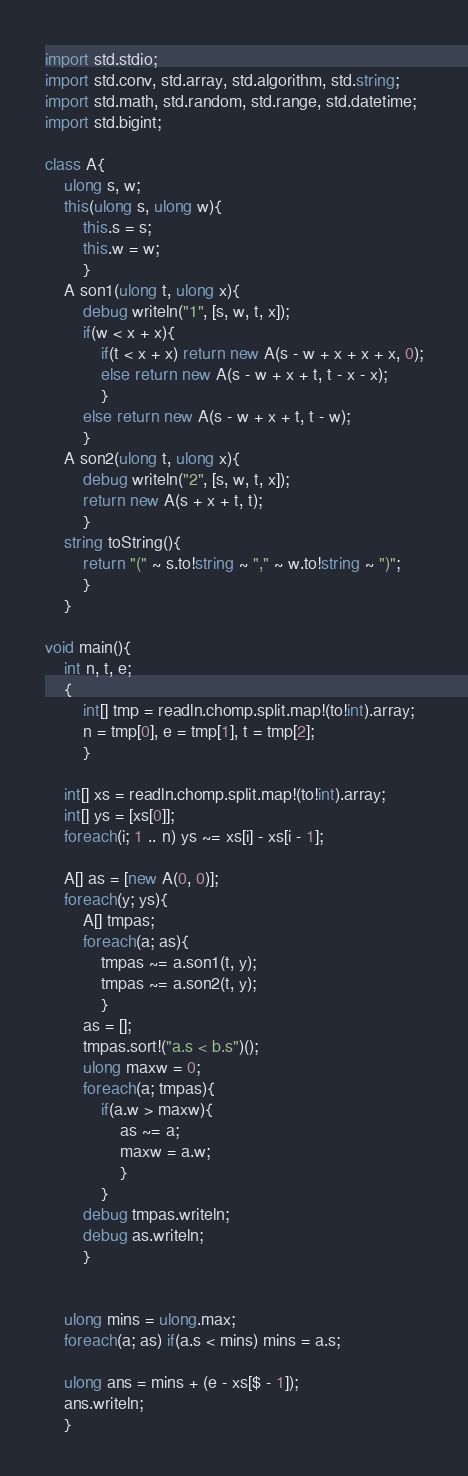Convert code to text. <code><loc_0><loc_0><loc_500><loc_500><_D_>import std.stdio;
import std.conv, std.array, std.algorithm, std.string;
import std.math, std.random, std.range, std.datetime;
import std.bigint;

class A{
	ulong s, w;
	this(ulong s, ulong w){
		this.s = s;
		this.w = w;
		}
	A son1(ulong t, ulong x){
		debug writeln("1", [s, w, t, x]);
		if(w < x + x){
			if(t < x + x) return new A(s - w + x + x + x, 0);
			else return new A(s - w + x + t, t - x - x);
			}
		else return new A(s - w + x + t, t - w);
		}
	A son2(ulong t, ulong x){
		debug writeln("2", [s, w, t, x]);
		return new A(s + x + t, t);
		}
	string toString(){
		return "(" ~ s.to!string ~ "," ~ w.to!string ~ ")";
		}
	}

void main(){
	int n, t, e;
	{
		int[] tmp = readln.chomp.split.map!(to!int).array;
		n = tmp[0], e = tmp[1], t = tmp[2];
		}
	
	int[] xs = readln.chomp.split.map!(to!int).array;
	int[] ys = [xs[0]];
	foreach(i; 1 .. n) ys ~= xs[i] - xs[i - 1];
	
	A[] as = [new A(0, 0)];
	foreach(y; ys){
		A[] tmpas;
		foreach(a; as){
			tmpas ~= a.son1(t, y);
			tmpas ~= a.son2(t, y);
			}
		as = [];
		tmpas.sort!("a.s < b.s")();
		ulong maxw = 0;
		foreach(a; tmpas){
			if(a.w > maxw){
				as ~= a;
				maxw = a.w;
				}
			}
		debug tmpas.writeln;
		debug as.writeln;
		}
	
	
	ulong mins = ulong.max;
	foreach(a; as) if(a.s < mins) mins = a.s;
	
	ulong ans = mins + (e - xs[$ - 1]);
	ans.writeln;
	}</code> 